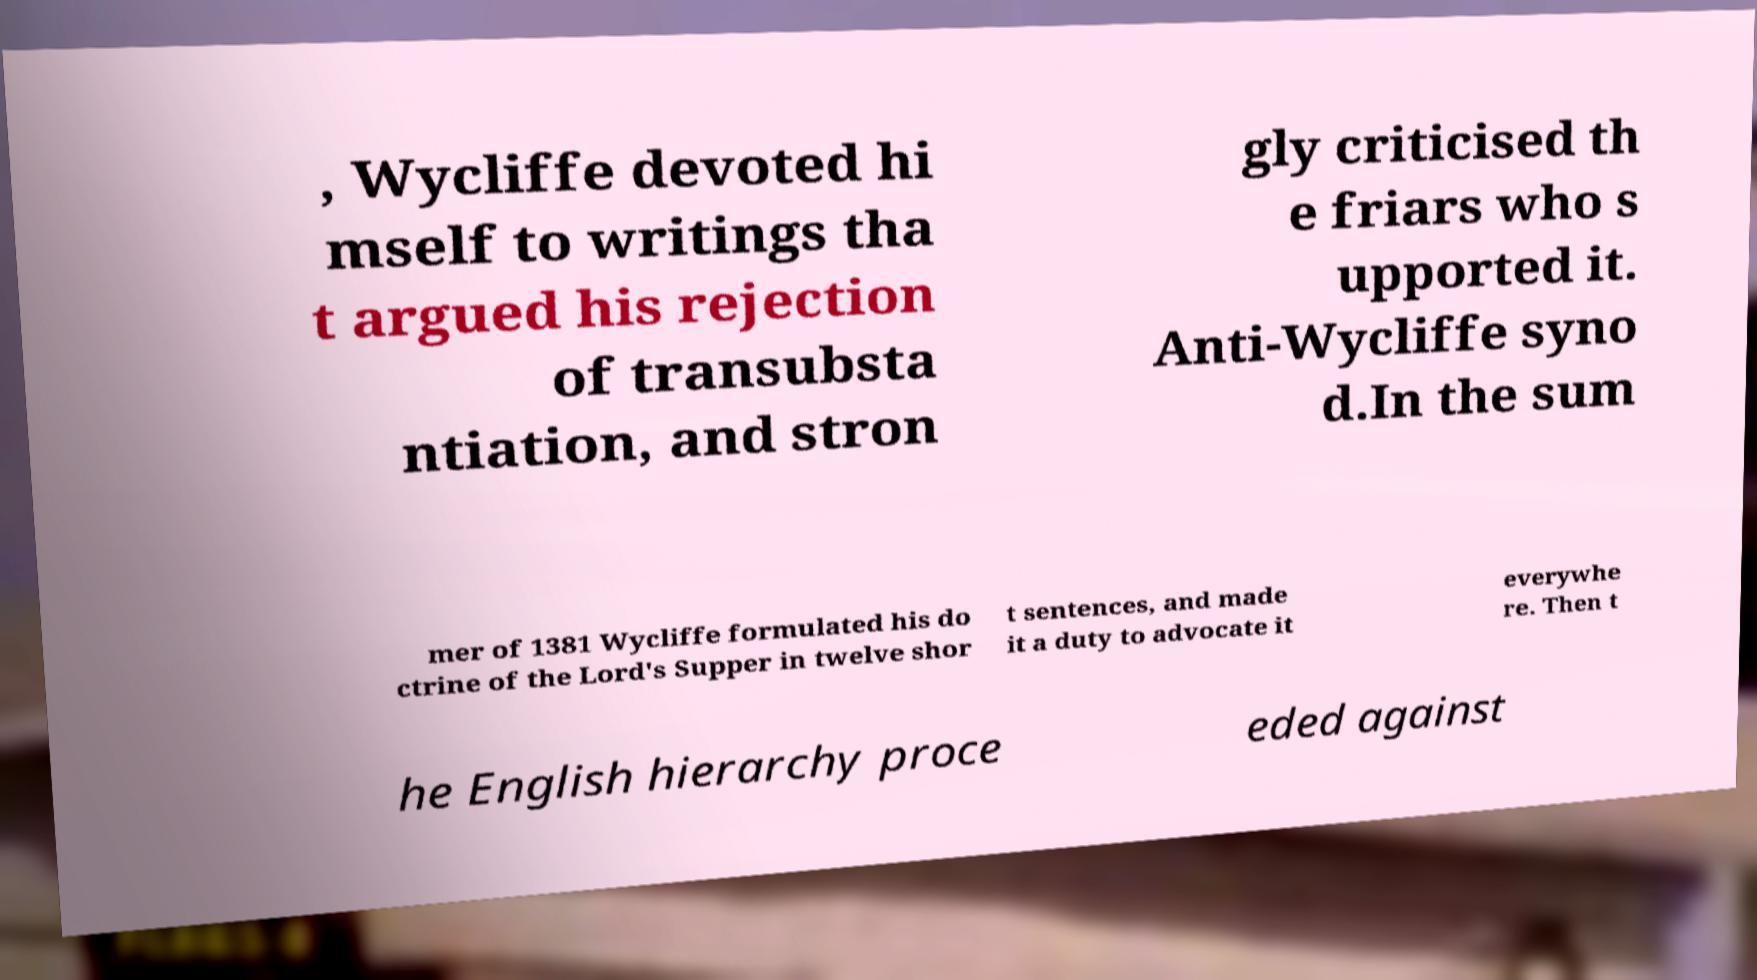Can you accurately transcribe the text from the provided image for me? , Wycliffe devoted hi mself to writings tha t argued his rejection of transubsta ntiation, and stron gly criticised th e friars who s upported it. Anti-Wycliffe syno d.In the sum mer of 1381 Wycliffe formulated his do ctrine of the Lord's Supper in twelve shor t sentences, and made it a duty to advocate it everywhe re. Then t he English hierarchy proce eded against 